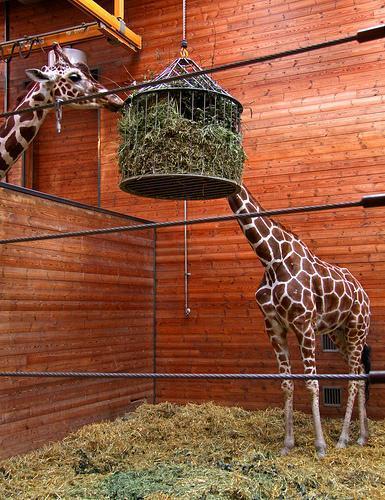How many animals are in the enclosed area?
Give a very brief answer. 2. 